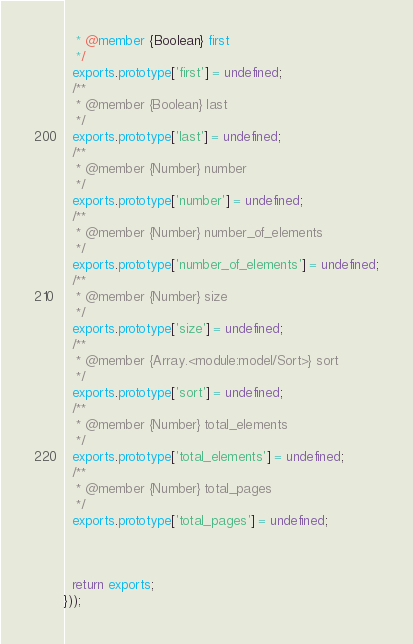<code> <loc_0><loc_0><loc_500><loc_500><_JavaScript_>   * @member {Boolean} first
   */
  exports.prototype['first'] = undefined;
  /**
   * @member {Boolean} last
   */
  exports.prototype['last'] = undefined;
  /**
   * @member {Number} number
   */
  exports.prototype['number'] = undefined;
  /**
   * @member {Number} number_of_elements
   */
  exports.prototype['number_of_elements'] = undefined;
  /**
   * @member {Number} size
   */
  exports.prototype['size'] = undefined;
  /**
   * @member {Array.<module:model/Sort>} sort
   */
  exports.prototype['sort'] = undefined;
  /**
   * @member {Number} total_elements
   */
  exports.prototype['total_elements'] = undefined;
  /**
   * @member {Number} total_pages
   */
  exports.prototype['total_pages'] = undefined;



  return exports;
}));


</code> 